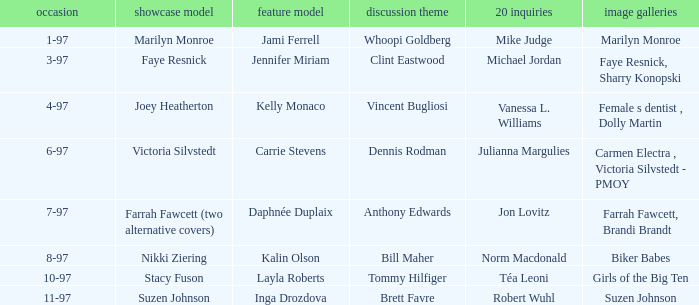Who was the centerfold model when a pictorial was done on marilyn monroe? Jami Ferrell. Parse the table in full. {'header': ['occasion', 'showcase model', 'feature model', 'discussion theme', '20 inquiries', 'image galleries'], 'rows': [['1-97', 'Marilyn Monroe', 'Jami Ferrell', 'Whoopi Goldberg', 'Mike Judge', 'Marilyn Monroe'], ['3-97', 'Faye Resnick', 'Jennifer Miriam', 'Clint Eastwood', 'Michael Jordan', 'Faye Resnick, Sharry Konopski'], ['4-97', 'Joey Heatherton', 'Kelly Monaco', 'Vincent Bugliosi', 'Vanessa L. Williams', 'Female s dentist , Dolly Martin'], ['6-97', 'Victoria Silvstedt', 'Carrie Stevens', 'Dennis Rodman', 'Julianna Margulies', 'Carmen Electra , Victoria Silvstedt - PMOY'], ['7-97', 'Farrah Fawcett (two alternative covers)', 'Daphnée Duplaix', 'Anthony Edwards', 'Jon Lovitz', 'Farrah Fawcett, Brandi Brandt'], ['8-97', 'Nikki Ziering', 'Kalin Olson', 'Bill Maher', 'Norm Macdonald', 'Biker Babes'], ['10-97', 'Stacy Fuson', 'Layla Roberts', 'Tommy Hilfiger', 'Téa Leoni', 'Girls of the Big Ten'], ['11-97', 'Suzen Johnson', 'Inga Drozdova', 'Brett Favre', 'Robert Wuhl', 'Suzen Johnson']]} 